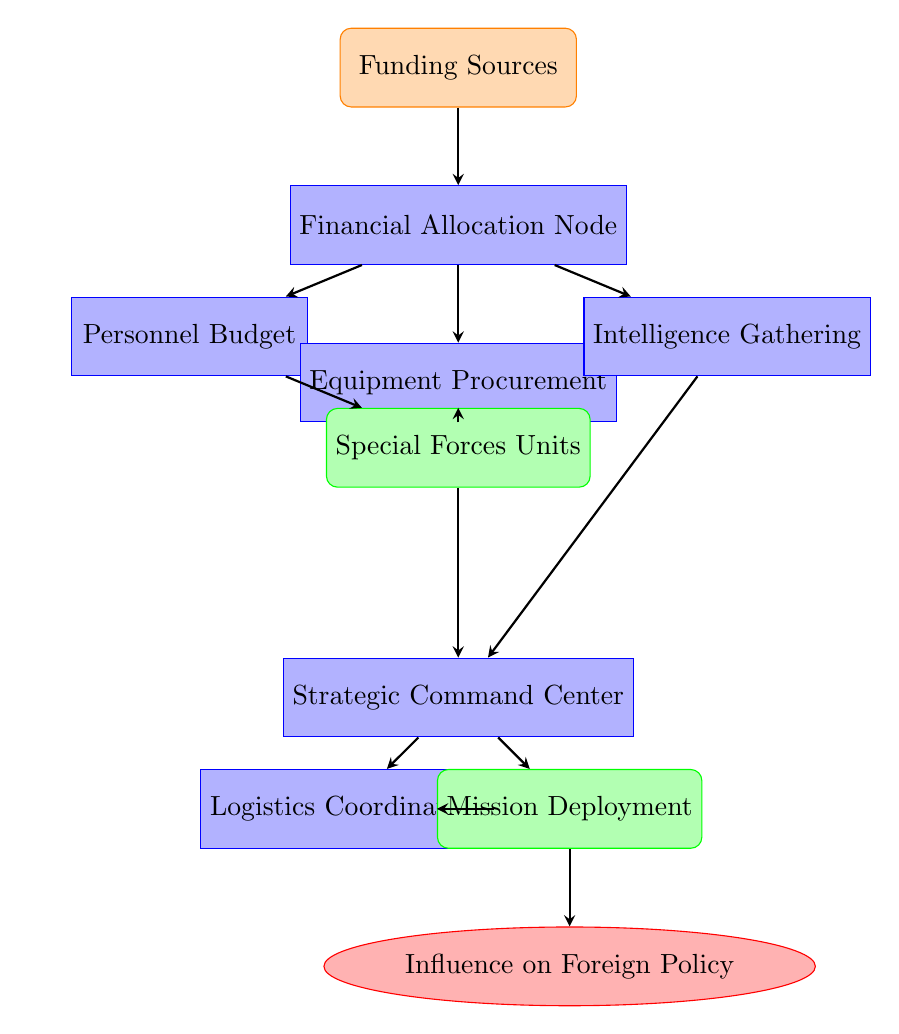What is the starting point for resource allocation? The starting point for resource allocation is labeled as "Funding Sources," which is the first input node in the diagram.
Answer: Funding Sources How many output nodes are present in the diagram? There are three output nodes: "Special Forces Units," "Mission Deployment," and "Influence on Foreign Policy."
Answer: 3 Which process node is related to personnel management? The process node related to personnel management is "Personnel Budget," which directly deals with the allocation of resources for personnel.
Answer: Personnel Budget What follows the "Strategic Command Center" in the flow of the diagram? Following the "Strategic Command Center," the next node in the flow is "Mission Deployment," which indicates the step taken after strategic planning.
Answer: Mission Deployment What type of resource does the "Equipment Procurement" node focus on? The "Equipment Procurement" node focuses on the acquisition of tools and resources necessary for the special forces, denoting a material resource type.
Answer: Equipment How does "Intelligence Gathering" contribute to "Mission Deployment"? "Intelligence Gathering" informs and supports the planning at the "Strategic Command Center," ensuring that the deployment of missions is based on accurate information.
Answer: Accurate information What is the final outcome of the resource allocation process? The final outcome of the resource allocation process, as indicated at the end of the flow, is "Influence on Foreign Policy," which signifies the overarching goal of deploying special forces.
Answer: Influence on Foreign Policy Which process node is connected to logistics? The process node connected to logistics is "Logistics Coordination," which is essential for managing resources and support for deployment.
Answer: Logistics Coordination What connects "Funding Sources" to "Personnel Budget"? The connection between "Funding Sources" and "Personnel Budget" is direct, indicating that funding is allocated to personnel management right after the initial source of funds.
Answer: Direct connection 